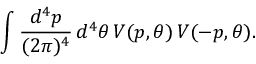<formula> <loc_0><loc_0><loc_500><loc_500>\int \frac { d ^ { 4 } p } { ( 2 \pi ) ^ { 4 } } \, d ^ { 4 } \theta \, V ( p , \theta ) \, V ( - p , \theta ) .</formula> 